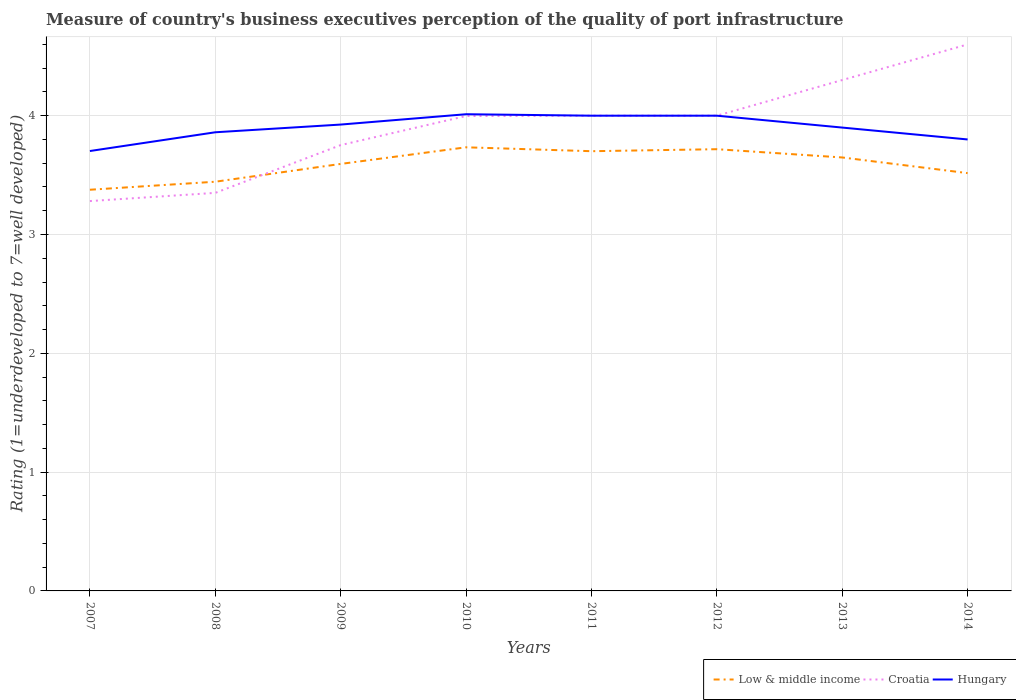Across all years, what is the maximum ratings of the quality of port infrastructure in Croatia?
Your answer should be compact. 3.28. What is the total ratings of the quality of port infrastructure in Hungary in the graph?
Keep it short and to the point. -0.3. What is the difference between the highest and the second highest ratings of the quality of port infrastructure in Croatia?
Your answer should be very brief. 1.32. How many lines are there?
Your answer should be compact. 3. How many years are there in the graph?
Give a very brief answer. 8. What is the difference between two consecutive major ticks on the Y-axis?
Provide a succinct answer. 1. Are the values on the major ticks of Y-axis written in scientific E-notation?
Your answer should be very brief. No. Where does the legend appear in the graph?
Your answer should be compact. Bottom right. How are the legend labels stacked?
Make the answer very short. Horizontal. What is the title of the graph?
Your response must be concise. Measure of country's business executives perception of the quality of port infrastructure. What is the label or title of the X-axis?
Make the answer very short. Years. What is the label or title of the Y-axis?
Your answer should be very brief. Rating (1=underdeveloped to 7=well developed). What is the Rating (1=underdeveloped to 7=well developed) in Low & middle income in 2007?
Give a very brief answer. 3.38. What is the Rating (1=underdeveloped to 7=well developed) in Croatia in 2007?
Offer a terse response. 3.28. What is the Rating (1=underdeveloped to 7=well developed) in Hungary in 2007?
Your answer should be very brief. 3.7. What is the Rating (1=underdeveloped to 7=well developed) in Low & middle income in 2008?
Make the answer very short. 3.44. What is the Rating (1=underdeveloped to 7=well developed) of Croatia in 2008?
Ensure brevity in your answer.  3.35. What is the Rating (1=underdeveloped to 7=well developed) of Hungary in 2008?
Ensure brevity in your answer.  3.86. What is the Rating (1=underdeveloped to 7=well developed) of Low & middle income in 2009?
Ensure brevity in your answer.  3.59. What is the Rating (1=underdeveloped to 7=well developed) in Croatia in 2009?
Provide a short and direct response. 3.75. What is the Rating (1=underdeveloped to 7=well developed) of Hungary in 2009?
Make the answer very short. 3.93. What is the Rating (1=underdeveloped to 7=well developed) of Low & middle income in 2010?
Give a very brief answer. 3.73. What is the Rating (1=underdeveloped to 7=well developed) of Croatia in 2010?
Give a very brief answer. 4. What is the Rating (1=underdeveloped to 7=well developed) of Hungary in 2010?
Make the answer very short. 4.01. What is the Rating (1=underdeveloped to 7=well developed) of Low & middle income in 2011?
Provide a succinct answer. 3.7. What is the Rating (1=underdeveloped to 7=well developed) in Croatia in 2011?
Keep it short and to the point. 4. What is the Rating (1=underdeveloped to 7=well developed) of Low & middle income in 2012?
Make the answer very short. 3.72. What is the Rating (1=underdeveloped to 7=well developed) of Hungary in 2012?
Your answer should be very brief. 4. What is the Rating (1=underdeveloped to 7=well developed) of Low & middle income in 2013?
Your answer should be compact. 3.65. What is the Rating (1=underdeveloped to 7=well developed) in Hungary in 2013?
Offer a very short reply. 3.9. What is the Rating (1=underdeveloped to 7=well developed) in Low & middle income in 2014?
Give a very brief answer. 3.52. What is the Rating (1=underdeveloped to 7=well developed) in Croatia in 2014?
Provide a succinct answer. 4.6. What is the Rating (1=underdeveloped to 7=well developed) of Hungary in 2014?
Your answer should be compact. 3.8. Across all years, what is the maximum Rating (1=underdeveloped to 7=well developed) in Low & middle income?
Make the answer very short. 3.73. Across all years, what is the maximum Rating (1=underdeveloped to 7=well developed) of Hungary?
Offer a very short reply. 4.01. Across all years, what is the minimum Rating (1=underdeveloped to 7=well developed) of Low & middle income?
Your answer should be compact. 3.38. Across all years, what is the minimum Rating (1=underdeveloped to 7=well developed) in Croatia?
Keep it short and to the point. 3.28. Across all years, what is the minimum Rating (1=underdeveloped to 7=well developed) of Hungary?
Your answer should be compact. 3.7. What is the total Rating (1=underdeveloped to 7=well developed) in Low & middle income in the graph?
Make the answer very short. 28.73. What is the total Rating (1=underdeveloped to 7=well developed) of Croatia in the graph?
Make the answer very short. 31.28. What is the total Rating (1=underdeveloped to 7=well developed) of Hungary in the graph?
Provide a short and direct response. 31.2. What is the difference between the Rating (1=underdeveloped to 7=well developed) of Low & middle income in 2007 and that in 2008?
Ensure brevity in your answer.  -0.07. What is the difference between the Rating (1=underdeveloped to 7=well developed) in Croatia in 2007 and that in 2008?
Keep it short and to the point. -0.07. What is the difference between the Rating (1=underdeveloped to 7=well developed) of Hungary in 2007 and that in 2008?
Make the answer very short. -0.16. What is the difference between the Rating (1=underdeveloped to 7=well developed) in Low & middle income in 2007 and that in 2009?
Provide a succinct answer. -0.22. What is the difference between the Rating (1=underdeveloped to 7=well developed) of Croatia in 2007 and that in 2009?
Provide a succinct answer. -0.47. What is the difference between the Rating (1=underdeveloped to 7=well developed) in Hungary in 2007 and that in 2009?
Ensure brevity in your answer.  -0.22. What is the difference between the Rating (1=underdeveloped to 7=well developed) in Low & middle income in 2007 and that in 2010?
Give a very brief answer. -0.36. What is the difference between the Rating (1=underdeveloped to 7=well developed) of Croatia in 2007 and that in 2010?
Ensure brevity in your answer.  -0.72. What is the difference between the Rating (1=underdeveloped to 7=well developed) in Hungary in 2007 and that in 2010?
Make the answer very short. -0.31. What is the difference between the Rating (1=underdeveloped to 7=well developed) in Low & middle income in 2007 and that in 2011?
Offer a very short reply. -0.32. What is the difference between the Rating (1=underdeveloped to 7=well developed) in Croatia in 2007 and that in 2011?
Your answer should be compact. -0.72. What is the difference between the Rating (1=underdeveloped to 7=well developed) of Hungary in 2007 and that in 2011?
Keep it short and to the point. -0.3. What is the difference between the Rating (1=underdeveloped to 7=well developed) of Low & middle income in 2007 and that in 2012?
Your answer should be compact. -0.34. What is the difference between the Rating (1=underdeveloped to 7=well developed) in Croatia in 2007 and that in 2012?
Ensure brevity in your answer.  -0.72. What is the difference between the Rating (1=underdeveloped to 7=well developed) of Hungary in 2007 and that in 2012?
Your answer should be very brief. -0.3. What is the difference between the Rating (1=underdeveloped to 7=well developed) in Low & middle income in 2007 and that in 2013?
Provide a short and direct response. -0.27. What is the difference between the Rating (1=underdeveloped to 7=well developed) in Croatia in 2007 and that in 2013?
Provide a short and direct response. -1.02. What is the difference between the Rating (1=underdeveloped to 7=well developed) of Hungary in 2007 and that in 2013?
Keep it short and to the point. -0.2. What is the difference between the Rating (1=underdeveloped to 7=well developed) in Low & middle income in 2007 and that in 2014?
Provide a short and direct response. -0.14. What is the difference between the Rating (1=underdeveloped to 7=well developed) of Croatia in 2007 and that in 2014?
Ensure brevity in your answer.  -1.32. What is the difference between the Rating (1=underdeveloped to 7=well developed) of Hungary in 2007 and that in 2014?
Keep it short and to the point. -0.1. What is the difference between the Rating (1=underdeveloped to 7=well developed) in Low & middle income in 2008 and that in 2009?
Offer a very short reply. -0.15. What is the difference between the Rating (1=underdeveloped to 7=well developed) in Croatia in 2008 and that in 2009?
Provide a short and direct response. -0.4. What is the difference between the Rating (1=underdeveloped to 7=well developed) of Hungary in 2008 and that in 2009?
Offer a very short reply. -0.06. What is the difference between the Rating (1=underdeveloped to 7=well developed) in Low & middle income in 2008 and that in 2010?
Offer a terse response. -0.29. What is the difference between the Rating (1=underdeveloped to 7=well developed) in Croatia in 2008 and that in 2010?
Your answer should be compact. -0.65. What is the difference between the Rating (1=underdeveloped to 7=well developed) in Hungary in 2008 and that in 2010?
Offer a very short reply. -0.15. What is the difference between the Rating (1=underdeveloped to 7=well developed) of Low & middle income in 2008 and that in 2011?
Provide a succinct answer. -0.26. What is the difference between the Rating (1=underdeveloped to 7=well developed) of Croatia in 2008 and that in 2011?
Offer a terse response. -0.65. What is the difference between the Rating (1=underdeveloped to 7=well developed) of Hungary in 2008 and that in 2011?
Your response must be concise. -0.14. What is the difference between the Rating (1=underdeveloped to 7=well developed) in Low & middle income in 2008 and that in 2012?
Your answer should be very brief. -0.27. What is the difference between the Rating (1=underdeveloped to 7=well developed) in Croatia in 2008 and that in 2012?
Your answer should be compact. -0.65. What is the difference between the Rating (1=underdeveloped to 7=well developed) in Hungary in 2008 and that in 2012?
Provide a short and direct response. -0.14. What is the difference between the Rating (1=underdeveloped to 7=well developed) in Low & middle income in 2008 and that in 2013?
Give a very brief answer. -0.2. What is the difference between the Rating (1=underdeveloped to 7=well developed) of Croatia in 2008 and that in 2013?
Provide a succinct answer. -0.95. What is the difference between the Rating (1=underdeveloped to 7=well developed) of Hungary in 2008 and that in 2013?
Offer a terse response. -0.04. What is the difference between the Rating (1=underdeveloped to 7=well developed) of Low & middle income in 2008 and that in 2014?
Ensure brevity in your answer.  -0.07. What is the difference between the Rating (1=underdeveloped to 7=well developed) in Croatia in 2008 and that in 2014?
Make the answer very short. -1.25. What is the difference between the Rating (1=underdeveloped to 7=well developed) of Hungary in 2008 and that in 2014?
Ensure brevity in your answer.  0.06. What is the difference between the Rating (1=underdeveloped to 7=well developed) of Low & middle income in 2009 and that in 2010?
Offer a very short reply. -0.14. What is the difference between the Rating (1=underdeveloped to 7=well developed) in Croatia in 2009 and that in 2010?
Your response must be concise. -0.24. What is the difference between the Rating (1=underdeveloped to 7=well developed) of Hungary in 2009 and that in 2010?
Your response must be concise. -0.09. What is the difference between the Rating (1=underdeveloped to 7=well developed) of Low & middle income in 2009 and that in 2011?
Make the answer very short. -0.11. What is the difference between the Rating (1=underdeveloped to 7=well developed) in Croatia in 2009 and that in 2011?
Your answer should be compact. -0.25. What is the difference between the Rating (1=underdeveloped to 7=well developed) in Hungary in 2009 and that in 2011?
Keep it short and to the point. -0.07. What is the difference between the Rating (1=underdeveloped to 7=well developed) of Low & middle income in 2009 and that in 2012?
Provide a succinct answer. -0.12. What is the difference between the Rating (1=underdeveloped to 7=well developed) of Croatia in 2009 and that in 2012?
Offer a very short reply. -0.25. What is the difference between the Rating (1=underdeveloped to 7=well developed) of Hungary in 2009 and that in 2012?
Provide a succinct answer. -0.07. What is the difference between the Rating (1=underdeveloped to 7=well developed) in Low & middle income in 2009 and that in 2013?
Your answer should be compact. -0.05. What is the difference between the Rating (1=underdeveloped to 7=well developed) in Croatia in 2009 and that in 2013?
Your answer should be very brief. -0.55. What is the difference between the Rating (1=underdeveloped to 7=well developed) in Hungary in 2009 and that in 2013?
Your response must be concise. 0.03. What is the difference between the Rating (1=underdeveloped to 7=well developed) in Low & middle income in 2009 and that in 2014?
Offer a terse response. 0.08. What is the difference between the Rating (1=underdeveloped to 7=well developed) of Croatia in 2009 and that in 2014?
Keep it short and to the point. -0.85. What is the difference between the Rating (1=underdeveloped to 7=well developed) in Hungary in 2009 and that in 2014?
Provide a short and direct response. 0.13. What is the difference between the Rating (1=underdeveloped to 7=well developed) of Low & middle income in 2010 and that in 2011?
Your answer should be very brief. 0.03. What is the difference between the Rating (1=underdeveloped to 7=well developed) of Croatia in 2010 and that in 2011?
Your response must be concise. -0. What is the difference between the Rating (1=underdeveloped to 7=well developed) of Hungary in 2010 and that in 2011?
Ensure brevity in your answer.  0.01. What is the difference between the Rating (1=underdeveloped to 7=well developed) of Low & middle income in 2010 and that in 2012?
Your answer should be compact. 0.02. What is the difference between the Rating (1=underdeveloped to 7=well developed) in Croatia in 2010 and that in 2012?
Ensure brevity in your answer.  -0. What is the difference between the Rating (1=underdeveloped to 7=well developed) in Hungary in 2010 and that in 2012?
Your answer should be very brief. 0.01. What is the difference between the Rating (1=underdeveloped to 7=well developed) in Low & middle income in 2010 and that in 2013?
Offer a terse response. 0.09. What is the difference between the Rating (1=underdeveloped to 7=well developed) of Croatia in 2010 and that in 2013?
Ensure brevity in your answer.  -0.3. What is the difference between the Rating (1=underdeveloped to 7=well developed) of Hungary in 2010 and that in 2013?
Your answer should be compact. 0.11. What is the difference between the Rating (1=underdeveloped to 7=well developed) of Low & middle income in 2010 and that in 2014?
Give a very brief answer. 0.22. What is the difference between the Rating (1=underdeveloped to 7=well developed) of Croatia in 2010 and that in 2014?
Your response must be concise. -0.6. What is the difference between the Rating (1=underdeveloped to 7=well developed) in Hungary in 2010 and that in 2014?
Your answer should be compact. 0.21. What is the difference between the Rating (1=underdeveloped to 7=well developed) of Low & middle income in 2011 and that in 2012?
Provide a short and direct response. -0.02. What is the difference between the Rating (1=underdeveloped to 7=well developed) of Croatia in 2011 and that in 2012?
Ensure brevity in your answer.  0. What is the difference between the Rating (1=underdeveloped to 7=well developed) in Low & middle income in 2011 and that in 2013?
Your answer should be very brief. 0.05. What is the difference between the Rating (1=underdeveloped to 7=well developed) of Low & middle income in 2011 and that in 2014?
Provide a short and direct response. 0.18. What is the difference between the Rating (1=underdeveloped to 7=well developed) in Croatia in 2011 and that in 2014?
Your answer should be very brief. -0.6. What is the difference between the Rating (1=underdeveloped to 7=well developed) of Low & middle income in 2012 and that in 2013?
Make the answer very short. 0.07. What is the difference between the Rating (1=underdeveloped to 7=well developed) in Croatia in 2012 and that in 2013?
Your answer should be very brief. -0.3. What is the difference between the Rating (1=underdeveloped to 7=well developed) in Hungary in 2012 and that in 2013?
Make the answer very short. 0.1. What is the difference between the Rating (1=underdeveloped to 7=well developed) in Low & middle income in 2012 and that in 2014?
Make the answer very short. 0.2. What is the difference between the Rating (1=underdeveloped to 7=well developed) in Hungary in 2012 and that in 2014?
Provide a short and direct response. 0.2. What is the difference between the Rating (1=underdeveloped to 7=well developed) of Low & middle income in 2013 and that in 2014?
Keep it short and to the point. 0.13. What is the difference between the Rating (1=underdeveloped to 7=well developed) in Hungary in 2013 and that in 2014?
Keep it short and to the point. 0.1. What is the difference between the Rating (1=underdeveloped to 7=well developed) in Low & middle income in 2007 and the Rating (1=underdeveloped to 7=well developed) in Croatia in 2008?
Give a very brief answer. 0.03. What is the difference between the Rating (1=underdeveloped to 7=well developed) in Low & middle income in 2007 and the Rating (1=underdeveloped to 7=well developed) in Hungary in 2008?
Make the answer very short. -0.48. What is the difference between the Rating (1=underdeveloped to 7=well developed) of Croatia in 2007 and the Rating (1=underdeveloped to 7=well developed) of Hungary in 2008?
Make the answer very short. -0.58. What is the difference between the Rating (1=underdeveloped to 7=well developed) in Low & middle income in 2007 and the Rating (1=underdeveloped to 7=well developed) in Croatia in 2009?
Your answer should be compact. -0.38. What is the difference between the Rating (1=underdeveloped to 7=well developed) in Low & middle income in 2007 and the Rating (1=underdeveloped to 7=well developed) in Hungary in 2009?
Your answer should be very brief. -0.55. What is the difference between the Rating (1=underdeveloped to 7=well developed) in Croatia in 2007 and the Rating (1=underdeveloped to 7=well developed) in Hungary in 2009?
Your answer should be very brief. -0.64. What is the difference between the Rating (1=underdeveloped to 7=well developed) in Low & middle income in 2007 and the Rating (1=underdeveloped to 7=well developed) in Croatia in 2010?
Provide a short and direct response. -0.62. What is the difference between the Rating (1=underdeveloped to 7=well developed) in Low & middle income in 2007 and the Rating (1=underdeveloped to 7=well developed) in Hungary in 2010?
Provide a succinct answer. -0.64. What is the difference between the Rating (1=underdeveloped to 7=well developed) of Croatia in 2007 and the Rating (1=underdeveloped to 7=well developed) of Hungary in 2010?
Make the answer very short. -0.73. What is the difference between the Rating (1=underdeveloped to 7=well developed) of Low & middle income in 2007 and the Rating (1=underdeveloped to 7=well developed) of Croatia in 2011?
Provide a succinct answer. -0.62. What is the difference between the Rating (1=underdeveloped to 7=well developed) in Low & middle income in 2007 and the Rating (1=underdeveloped to 7=well developed) in Hungary in 2011?
Your response must be concise. -0.62. What is the difference between the Rating (1=underdeveloped to 7=well developed) of Croatia in 2007 and the Rating (1=underdeveloped to 7=well developed) of Hungary in 2011?
Your response must be concise. -0.72. What is the difference between the Rating (1=underdeveloped to 7=well developed) in Low & middle income in 2007 and the Rating (1=underdeveloped to 7=well developed) in Croatia in 2012?
Make the answer very short. -0.62. What is the difference between the Rating (1=underdeveloped to 7=well developed) in Low & middle income in 2007 and the Rating (1=underdeveloped to 7=well developed) in Hungary in 2012?
Keep it short and to the point. -0.62. What is the difference between the Rating (1=underdeveloped to 7=well developed) in Croatia in 2007 and the Rating (1=underdeveloped to 7=well developed) in Hungary in 2012?
Offer a terse response. -0.72. What is the difference between the Rating (1=underdeveloped to 7=well developed) in Low & middle income in 2007 and the Rating (1=underdeveloped to 7=well developed) in Croatia in 2013?
Your answer should be very brief. -0.92. What is the difference between the Rating (1=underdeveloped to 7=well developed) of Low & middle income in 2007 and the Rating (1=underdeveloped to 7=well developed) of Hungary in 2013?
Your response must be concise. -0.52. What is the difference between the Rating (1=underdeveloped to 7=well developed) in Croatia in 2007 and the Rating (1=underdeveloped to 7=well developed) in Hungary in 2013?
Offer a very short reply. -0.62. What is the difference between the Rating (1=underdeveloped to 7=well developed) of Low & middle income in 2007 and the Rating (1=underdeveloped to 7=well developed) of Croatia in 2014?
Offer a very short reply. -1.22. What is the difference between the Rating (1=underdeveloped to 7=well developed) of Low & middle income in 2007 and the Rating (1=underdeveloped to 7=well developed) of Hungary in 2014?
Make the answer very short. -0.42. What is the difference between the Rating (1=underdeveloped to 7=well developed) of Croatia in 2007 and the Rating (1=underdeveloped to 7=well developed) of Hungary in 2014?
Offer a very short reply. -0.52. What is the difference between the Rating (1=underdeveloped to 7=well developed) of Low & middle income in 2008 and the Rating (1=underdeveloped to 7=well developed) of Croatia in 2009?
Ensure brevity in your answer.  -0.31. What is the difference between the Rating (1=underdeveloped to 7=well developed) of Low & middle income in 2008 and the Rating (1=underdeveloped to 7=well developed) of Hungary in 2009?
Provide a succinct answer. -0.48. What is the difference between the Rating (1=underdeveloped to 7=well developed) of Croatia in 2008 and the Rating (1=underdeveloped to 7=well developed) of Hungary in 2009?
Provide a short and direct response. -0.57. What is the difference between the Rating (1=underdeveloped to 7=well developed) of Low & middle income in 2008 and the Rating (1=underdeveloped to 7=well developed) of Croatia in 2010?
Your response must be concise. -0.55. What is the difference between the Rating (1=underdeveloped to 7=well developed) in Low & middle income in 2008 and the Rating (1=underdeveloped to 7=well developed) in Hungary in 2010?
Make the answer very short. -0.57. What is the difference between the Rating (1=underdeveloped to 7=well developed) in Croatia in 2008 and the Rating (1=underdeveloped to 7=well developed) in Hungary in 2010?
Keep it short and to the point. -0.66. What is the difference between the Rating (1=underdeveloped to 7=well developed) of Low & middle income in 2008 and the Rating (1=underdeveloped to 7=well developed) of Croatia in 2011?
Ensure brevity in your answer.  -0.56. What is the difference between the Rating (1=underdeveloped to 7=well developed) of Low & middle income in 2008 and the Rating (1=underdeveloped to 7=well developed) of Hungary in 2011?
Keep it short and to the point. -0.56. What is the difference between the Rating (1=underdeveloped to 7=well developed) in Croatia in 2008 and the Rating (1=underdeveloped to 7=well developed) in Hungary in 2011?
Offer a very short reply. -0.65. What is the difference between the Rating (1=underdeveloped to 7=well developed) of Low & middle income in 2008 and the Rating (1=underdeveloped to 7=well developed) of Croatia in 2012?
Your answer should be compact. -0.56. What is the difference between the Rating (1=underdeveloped to 7=well developed) of Low & middle income in 2008 and the Rating (1=underdeveloped to 7=well developed) of Hungary in 2012?
Ensure brevity in your answer.  -0.56. What is the difference between the Rating (1=underdeveloped to 7=well developed) in Croatia in 2008 and the Rating (1=underdeveloped to 7=well developed) in Hungary in 2012?
Ensure brevity in your answer.  -0.65. What is the difference between the Rating (1=underdeveloped to 7=well developed) in Low & middle income in 2008 and the Rating (1=underdeveloped to 7=well developed) in Croatia in 2013?
Give a very brief answer. -0.86. What is the difference between the Rating (1=underdeveloped to 7=well developed) of Low & middle income in 2008 and the Rating (1=underdeveloped to 7=well developed) of Hungary in 2013?
Provide a succinct answer. -0.46. What is the difference between the Rating (1=underdeveloped to 7=well developed) of Croatia in 2008 and the Rating (1=underdeveloped to 7=well developed) of Hungary in 2013?
Your answer should be very brief. -0.55. What is the difference between the Rating (1=underdeveloped to 7=well developed) of Low & middle income in 2008 and the Rating (1=underdeveloped to 7=well developed) of Croatia in 2014?
Provide a short and direct response. -1.16. What is the difference between the Rating (1=underdeveloped to 7=well developed) in Low & middle income in 2008 and the Rating (1=underdeveloped to 7=well developed) in Hungary in 2014?
Your answer should be compact. -0.36. What is the difference between the Rating (1=underdeveloped to 7=well developed) in Croatia in 2008 and the Rating (1=underdeveloped to 7=well developed) in Hungary in 2014?
Your answer should be compact. -0.45. What is the difference between the Rating (1=underdeveloped to 7=well developed) of Low & middle income in 2009 and the Rating (1=underdeveloped to 7=well developed) of Croatia in 2010?
Your answer should be compact. -0.4. What is the difference between the Rating (1=underdeveloped to 7=well developed) in Low & middle income in 2009 and the Rating (1=underdeveloped to 7=well developed) in Hungary in 2010?
Keep it short and to the point. -0.42. What is the difference between the Rating (1=underdeveloped to 7=well developed) in Croatia in 2009 and the Rating (1=underdeveloped to 7=well developed) in Hungary in 2010?
Provide a short and direct response. -0.26. What is the difference between the Rating (1=underdeveloped to 7=well developed) in Low & middle income in 2009 and the Rating (1=underdeveloped to 7=well developed) in Croatia in 2011?
Ensure brevity in your answer.  -0.41. What is the difference between the Rating (1=underdeveloped to 7=well developed) of Low & middle income in 2009 and the Rating (1=underdeveloped to 7=well developed) of Hungary in 2011?
Give a very brief answer. -0.41. What is the difference between the Rating (1=underdeveloped to 7=well developed) of Croatia in 2009 and the Rating (1=underdeveloped to 7=well developed) of Hungary in 2011?
Provide a succinct answer. -0.25. What is the difference between the Rating (1=underdeveloped to 7=well developed) of Low & middle income in 2009 and the Rating (1=underdeveloped to 7=well developed) of Croatia in 2012?
Give a very brief answer. -0.41. What is the difference between the Rating (1=underdeveloped to 7=well developed) in Low & middle income in 2009 and the Rating (1=underdeveloped to 7=well developed) in Hungary in 2012?
Your answer should be compact. -0.41. What is the difference between the Rating (1=underdeveloped to 7=well developed) of Croatia in 2009 and the Rating (1=underdeveloped to 7=well developed) of Hungary in 2012?
Make the answer very short. -0.25. What is the difference between the Rating (1=underdeveloped to 7=well developed) of Low & middle income in 2009 and the Rating (1=underdeveloped to 7=well developed) of Croatia in 2013?
Offer a very short reply. -0.71. What is the difference between the Rating (1=underdeveloped to 7=well developed) of Low & middle income in 2009 and the Rating (1=underdeveloped to 7=well developed) of Hungary in 2013?
Provide a succinct answer. -0.31. What is the difference between the Rating (1=underdeveloped to 7=well developed) in Croatia in 2009 and the Rating (1=underdeveloped to 7=well developed) in Hungary in 2013?
Your response must be concise. -0.15. What is the difference between the Rating (1=underdeveloped to 7=well developed) of Low & middle income in 2009 and the Rating (1=underdeveloped to 7=well developed) of Croatia in 2014?
Ensure brevity in your answer.  -1.01. What is the difference between the Rating (1=underdeveloped to 7=well developed) of Low & middle income in 2009 and the Rating (1=underdeveloped to 7=well developed) of Hungary in 2014?
Offer a very short reply. -0.21. What is the difference between the Rating (1=underdeveloped to 7=well developed) of Croatia in 2009 and the Rating (1=underdeveloped to 7=well developed) of Hungary in 2014?
Your answer should be very brief. -0.05. What is the difference between the Rating (1=underdeveloped to 7=well developed) of Low & middle income in 2010 and the Rating (1=underdeveloped to 7=well developed) of Croatia in 2011?
Your answer should be very brief. -0.27. What is the difference between the Rating (1=underdeveloped to 7=well developed) of Low & middle income in 2010 and the Rating (1=underdeveloped to 7=well developed) of Hungary in 2011?
Ensure brevity in your answer.  -0.27. What is the difference between the Rating (1=underdeveloped to 7=well developed) in Croatia in 2010 and the Rating (1=underdeveloped to 7=well developed) in Hungary in 2011?
Provide a short and direct response. -0. What is the difference between the Rating (1=underdeveloped to 7=well developed) of Low & middle income in 2010 and the Rating (1=underdeveloped to 7=well developed) of Croatia in 2012?
Keep it short and to the point. -0.27. What is the difference between the Rating (1=underdeveloped to 7=well developed) of Low & middle income in 2010 and the Rating (1=underdeveloped to 7=well developed) of Hungary in 2012?
Provide a short and direct response. -0.27. What is the difference between the Rating (1=underdeveloped to 7=well developed) of Croatia in 2010 and the Rating (1=underdeveloped to 7=well developed) of Hungary in 2012?
Give a very brief answer. -0. What is the difference between the Rating (1=underdeveloped to 7=well developed) of Low & middle income in 2010 and the Rating (1=underdeveloped to 7=well developed) of Croatia in 2013?
Keep it short and to the point. -0.57. What is the difference between the Rating (1=underdeveloped to 7=well developed) in Low & middle income in 2010 and the Rating (1=underdeveloped to 7=well developed) in Hungary in 2013?
Your answer should be compact. -0.17. What is the difference between the Rating (1=underdeveloped to 7=well developed) in Croatia in 2010 and the Rating (1=underdeveloped to 7=well developed) in Hungary in 2013?
Give a very brief answer. 0.1. What is the difference between the Rating (1=underdeveloped to 7=well developed) in Low & middle income in 2010 and the Rating (1=underdeveloped to 7=well developed) in Croatia in 2014?
Keep it short and to the point. -0.87. What is the difference between the Rating (1=underdeveloped to 7=well developed) in Low & middle income in 2010 and the Rating (1=underdeveloped to 7=well developed) in Hungary in 2014?
Your answer should be compact. -0.07. What is the difference between the Rating (1=underdeveloped to 7=well developed) in Croatia in 2010 and the Rating (1=underdeveloped to 7=well developed) in Hungary in 2014?
Offer a terse response. 0.2. What is the difference between the Rating (1=underdeveloped to 7=well developed) in Low & middle income in 2011 and the Rating (1=underdeveloped to 7=well developed) in Croatia in 2012?
Offer a very short reply. -0.3. What is the difference between the Rating (1=underdeveloped to 7=well developed) of Low & middle income in 2011 and the Rating (1=underdeveloped to 7=well developed) of Hungary in 2012?
Offer a terse response. -0.3. What is the difference between the Rating (1=underdeveloped to 7=well developed) of Croatia in 2011 and the Rating (1=underdeveloped to 7=well developed) of Hungary in 2012?
Give a very brief answer. 0. What is the difference between the Rating (1=underdeveloped to 7=well developed) in Low & middle income in 2011 and the Rating (1=underdeveloped to 7=well developed) in Croatia in 2013?
Keep it short and to the point. -0.6. What is the difference between the Rating (1=underdeveloped to 7=well developed) in Low & middle income in 2011 and the Rating (1=underdeveloped to 7=well developed) in Hungary in 2013?
Keep it short and to the point. -0.2. What is the difference between the Rating (1=underdeveloped to 7=well developed) in Low & middle income in 2011 and the Rating (1=underdeveloped to 7=well developed) in Croatia in 2014?
Make the answer very short. -0.9. What is the difference between the Rating (1=underdeveloped to 7=well developed) of Low & middle income in 2011 and the Rating (1=underdeveloped to 7=well developed) of Hungary in 2014?
Provide a succinct answer. -0.1. What is the difference between the Rating (1=underdeveloped to 7=well developed) of Low & middle income in 2012 and the Rating (1=underdeveloped to 7=well developed) of Croatia in 2013?
Offer a terse response. -0.58. What is the difference between the Rating (1=underdeveloped to 7=well developed) of Low & middle income in 2012 and the Rating (1=underdeveloped to 7=well developed) of Hungary in 2013?
Offer a very short reply. -0.18. What is the difference between the Rating (1=underdeveloped to 7=well developed) in Low & middle income in 2012 and the Rating (1=underdeveloped to 7=well developed) in Croatia in 2014?
Provide a short and direct response. -0.88. What is the difference between the Rating (1=underdeveloped to 7=well developed) in Low & middle income in 2012 and the Rating (1=underdeveloped to 7=well developed) in Hungary in 2014?
Provide a succinct answer. -0.08. What is the difference between the Rating (1=underdeveloped to 7=well developed) of Low & middle income in 2013 and the Rating (1=underdeveloped to 7=well developed) of Croatia in 2014?
Make the answer very short. -0.95. What is the difference between the Rating (1=underdeveloped to 7=well developed) in Low & middle income in 2013 and the Rating (1=underdeveloped to 7=well developed) in Hungary in 2014?
Ensure brevity in your answer.  -0.15. What is the difference between the Rating (1=underdeveloped to 7=well developed) in Croatia in 2013 and the Rating (1=underdeveloped to 7=well developed) in Hungary in 2014?
Offer a very short reply. 0.5. What is the average Rating (1=underdeveloped to 7=well developed) of Low & middle income per year?
Provide a short and direct response. 3.59. What is the average Rating (1=underdeveloped to 7=well developed) in Croatia per year?
Keep it short and to the point. 3.91. What is the average Rating (1=underdeveloped to 7=well developed) of Hungary per year?
Your response must be concise. 3.9. In the year 2007, what is the difference between the Rating (1=underdeveloped to 7=well developed) of Low & middle income and Rating (1=underdeveloped to 7=well developed) of Croatia?
Your answer should be very brief. 0.1. In the year 2007, what is the difference between the Rating (1=underdeveloped to 7=well developed) in Low & middle income and Rating (1=underdeveloped to 7=well developed) in Hungary?
Keep it short and to the point. -0.33. In the year 2007, what is the difference between the Rating (1=underdeveloped to 7=well developed) in Croatia and Rating (1=underdeveloped to 7=well developed) in Hungary?
Provide a short and direct response. -0.42. In the year 2008, what is the difference between the Rating (1=underdeveloped to 7=well developed) in Low & middle income and Rating (1=underdeveloped to 7=well developed) in Croatia?
Give a very brief answer. 0.09. In the year 2008, what is the difference between the Rating (1=underdeveloped to 7=well developed) in Low & middle income and Rating (1=underdeveloped to 7=well developed) in Hungary?
Offer a very short reply. -0.42. In the year 2008, what is the difference between the Rating (1=underdeveloped to 7=well developed) in Croatia and Rating (1=underdeveloped to 7=well developed) in Hungary?
Provide a short and direct response. -0.51. In the year 2009, what is the difference between the Rating (1=underdeveloped to 7=well developed) in Low & middle income and Rating (1=underdeveloped to 7=well developed) in Croatia?
Ensure brevity in your answer.  -0.16. In the year 2009, what is the difference between the Rating (1=underdeveloped to 7=well developed) of Low & middle income and Rating (1=underdeveloped to 7=well developed) of Hungary?
Offer a very short reply. -0.33. In the year 2009, what is the difference between the Rating (1=underdeveloped to 7=well developed) in Croatia and Rating (1=underdeveloped to 7=well developed) in Hungary?
Offer a very short reply. -0.17. In the year 2010, what is the difference between the Rating (1=underdeveloped to 7=well developed) of Low & middle income and Rating (1=underdeveloped to 7=well developed) of Croatia?
Your answer should be very brief. -0.26. In the year 2010, what is the difference between the Rating (1=underdeveloped to 7=well developed) in Low & middle income and Rating (1=underdeveloped to 7=well developed) in Hungary?
Your answer should be very brief. -0.28. In the year 2010, what is the difference between the Rating (1=underdeveloped to 7=well developed) of Croatia and Rating (1=underdeveloped to 7=well developed) of Hungary?
Your answer should be compact. -0.01. In the year 2011, what is the difference between the Rating (1=underdeveloped to 7=well developed) of Low & middle income and Rating (1=underdeveloped to 7=well developed) of Croatia?
Keep it short and to the point. -0.3. In the year 2011, what is the difference between the Rating (1=underdeveloped to 7=well developed) of Low & middle income and Rating (1=underdeveloped to 7=well developed) of Hungary?
Make the answer very short. -0.3. In the year 2012, what is the difference between the Rating (1=underdeveloped to 7=well developed) of Low & middle income and Rating (1=underdeveloped to 7=well developed) of Croatia?
Your answer should be very brief. -0.28. In the year 2012, what is the difference between the Rating (1=underdeveloped to 7=well developed) in Low & middle income and Rating (1=underdeveloped to 7=well developed) in Hungary?
Your answer should be compact. -0.28. In the year 2012, what is the difference between the Rating (1=underdeveloped to 7=well developed) in Croatia and Rating (1=underdeveloped to 7=well developed) in Hungary?
Provide a succinct answer. 0. In the year 2013, what is the difference between the Rating (1=underdeveloped to 7=well developed) in Low & middle income and Rating (1=underdeveloped to 7=well developed) in Croatia?
Provide a short and direct response. -0.65. In the year 2013, what is the difference between the Rating (1=underdeveloped to 7=well developed) in Low & middle income and Rating (1=underdeveloped to 7=well developed) in Hungary?
Provide a succinct answer. -0.25. In the year 2013, what is the difference between the Rating (1=underdeveloped to 7=well developed) of Croatia and Rating (1=underdeveloped to 7=well developed) of Hungary?
Your answer should be very brief. 0.4. In the year 2014, what is the difference between the Rating (1=underdeveloped to 7=well developed) in Low & middle income and Rating (1=underdeveloped to 7=well developed) in Croatia?
Provide a short and direct response. -1.08. In the year 2014, what is the difference between the Rating (1=underdeveloped to 7=well developed) of Low & middle income and Rating (1=underdeveloped to 7=well developed) of Hungary?
Keep it short and to the point. -0.28. What is the ratio of the Rating (1=underdeveloped to 7=well developed) of Low & middle income in 2007 to that in 2008?
Your response must be concise. 0.98. What is the ratio of the Rating (1=underdeveloped to 7=well developed) in Croatia in 2007 to that in 2008?
Offer a very short reply. 0.98. What is the ratio of the Rating (1=underdeveloped to 7=well developed) in Hungary in 2007 to that in 2008?
Offer a very short reply. 0.96. What is the ratio of the Rating (1=underdeveloped to 7=well developed) in Low & middle income in 2007 to that in 2009?
Offer a very short reply. 0.94. What is the ratio of the Rating (1=underdeveloped to 7=well developed) in Croatia in 2007 to that in 2009?
Give a very brief answer. 0.87. What is the ratio of the Rating (1=underdeveloped to 7=well developed) of Hungary in 2007 to that in 2009?
Your answer should be compact. 0.94. What is the ratio of the Rating (1=underdeveloped to 7=well developed) in Low & middle income in 2007 to that in 2010?
Offer a very short reply. 0.9. What is the ratio of the Rating (1=underdeveloped to 7=well developed) in Croatia in 2007 to that in 2010?
Give a very brief answer. 0.82. What is the ratio of the Rating (1=underdeveloped to 7=well developed) of Hungary in 2007 to that in 2010?
Your response must be concise. 0.92. What is the ratio of the Rating (1=underdeveloped to 7=well developed) in Low & middle income in 2007 to that in 2011?
Keep it short and to the point. 0.91. What is the ratio of the Rating (1=underdeveloped to 7=well developed) in Croatia in 2007 to that in 2011?
Keep it short and to the point. 0.82. What is the ratio of the Rating (1=underdeveloped to 7=well developed) of Hungary in 2007 to that in 2011?
Offer a very short reply. 0.93. What is the ratio of the Rating (1=underdeveloped to 7=well developed) in Low & middle income in 2007 to that in 2012?
Make the answer very short. 0.91. What is the ratio of the Rating (1=underdeveloped to 7=well developed) in Croatia in 2007 to that in 2012?
Give a very brief answer. 0.82. What is the ratio of the Rating (1=underdeveloped to 7=well developed) in Hungary in 2007 to that in 2012?
Keep it short and to the point. 0.93. What is the ratio of the Rating (1=underdeveloped to 7=well developed) of Low & middle income in 2007 to that in 2013?
Offer a very short reply. 0.93. What is the ratio of the Rating (1=underdeveloped to 7=well developed) of Croatia in 2007 to that in 2013?
Ensure brevity in your answer.  0.76. What is the ratio of the Rating (1=underdeveloped to 7=well developed) in Hungary in 2007 to that in 2013?
Provide a succinct answer. 0.95. What is the ratio of the Rating (1=underdeveloped to 7=well developed) in Low & middle income in 2007 to that in 2014?
Offer a very short reply. 0.96. What is the ratio of the Rating (1=underdeveloped to 7=well developed) in Croatia in 2007 to that in 2014?
Provide a succinct answer. 0.71. What is the ratio of the Rating (1=underdeveloped to 7=well developed) in Hungary in 2007 to that in 2014?
Give a very brief answer. 0.97. What is the ratio of the Rating (1=underdeveloped to 7=well developed) in Croatia in 2008 to that in 2009?
Provide a succinct answer. 0.89. What is the ratio of the Rating (1=underdeveloped to 7=well developed) of Hungary in 2008 to that in 2009?
Make the answer very short. 0.98. What is the ratio of the Rating (1=underdeveloped to 7=well developed) of Low & middle income in 2008 to that in 2010?
Provide a short and direct response. 0.92. What is the ratio of the Rating (1=underdeveloped to 7=well developed) in Croatia in 2008 to that in 2010?
Offer a very short reply. 0.84. What is the ratio of the Rating (1=underdeveloped to 7=well developed) in Hungary in 2008 to that in 2010?
Ensure brevity in your answer.  0.96. What is the ratio of the Rating (1=underdeveloped to 7=well developed) of Low & middle income in 2008 to that in 2011?
Offer a very short reply. 0.93. What is the ratio of the Rating (1=underdeveloped to 7=well developed) of Croatia in 2008 to that in 2011?
Offer a terse response. 0.84. What is the ratio of the Rating (1=underdeveloped to 7=well developed) in Hungary in 2008 to that in 2011?
Your answer should be compact. 0.97. What is the ratio of the Rating (1=underdeveloped to 7=well developed) of Low & middle income in 2008 to that in 2012?
Offer a terse response. 0.93. What is the ratio of the Rating (1=underdeveloped to 7=well developed) of Croatia in 2008 to that in 2012?
Your response must be concise. 0.84. What is the ratio of the Rating (1=underdeveloped to 7=well developed) of Hungary in 2008 to that in 2012?
Provide a short and direct response. 0.97. What is the ratio of the Rating (1=underdeveloped to 7=well developed) of Low & middle income in 2008 to that in 2013?
Your answer should be very brief. 0.94. What is the ratio of the Rating (1=underdeveloped to 7=well developed) in Croatia in 2008 to that in 2013?
Give a very brief answer. 0.78. What is the ratio of the Rating (1=underdeveloped to 7=well developed) in Low & middle income in 2008 to that in 2014?
Provide a succinct answer. 0.98. What is the ratio of the Rating (1=underdeveloped to 7=well developed) of Croatia in 2008 to that in 2014?
Your answer should be compact. 0.73. What is the ratio of the Rating (1=underdeveloped to 7=well developed) of Hungary in 2008 to that in 2014?
Make the answer very short. 1.02. What is the ratio of the Rating (1=underdeveloped to 7=well developed) in Low & middle income in 2009 to that in 2010?
Your answer should be compact. 0.96. What is the ratio of the Rating (1=underdeveloped to 7=well developed) of Croatia in 2009 to that in 2010?
Offer a terse response. 0.94. What is the ratio of the Rating (1=underdeveloped to 7=well developed) in Hungary in 2009 to that in 2010?
Keep it short and to the point. 0.98. What is the ratio of the Rating (1=underdeveloped to 7=well developed) in Low & middle income in 2009 to that in 2011?
Provide a succinct answer. 0.97. What is the ratio of the Rating (1=underdeveloped to 7=well developed) in Croatia in 2009 to that in 2011?
Give a very brief answer. 0.94. What is the ratio of the Rating (1=underdeveloped to 7=well developed) of Hungary in 2009 to that in 2011?
Provide a succinct answer. 0.98. What is the ratio of the Rating (1=underdeveloped to 7=well developed) in Low & middle income in 2009 to that in 2012?
Offer a terse response. 0.97. What is the ratio of the Rating (1=underdeveloped to 7=well developed) of Croatia in 2009 to that in 2012?
Give a very brief answer. 0.94. What is the ratio of the Rating (1=underdeveloped to 7=well developed) in Hungary in 2009 to that in 2012?
Ensure brevity in your answer.  0.98. What is the ratio of the Rating (1=underdeveloped to 7=well developed) of Low & middle income in 2009 to that in 2013?
Make the answer very short. 0.99. What is the ratio of the Rating (1=underdeveloped to 7=well developed) in Croatia in 2009 to that in 2013?
Offer a terse response. 0.87. What is the ratio of the Rating (1=underdeveloped to 7=well developed) of Croatia in 2009 to that in 2014?
Provide a succinct answer. 0.82. What is the ratio of the Rating (1=underdeveloped to 7=well developed) in Hungary in 2009 to that in 2014?
Give a very brief answer. 1.03. What is the ratio of the Rating (1=underdeveloped to 7=well developed) of Low & middle income in 2010 to that in 2011?
Offer a very short reply. 1.01. What is the ratio of the Rating (1=underdeveloped to 7=well developed) of Croatia in 2010 to that in 2011?
Offer a very short reply. 1. What is the ratio of the Rating (1=underdeveloped to 7=well developed) of Hungary in 2010 to that in 2011?
Provide a short and direct response. 1. What is the ratio of the Rating (1=underdeveloped to 7=well developed) of Croatia in 2010 to that in 2012?
Provide a succinct answer. 1. What is the ratio of the Rating (1=underdeveloped to 7=well developed) of Low & middle income in 2010 to that in 2013?
Your answer should be very brief. 1.02. What is the ratio of the Rating (1=underdeveloped to 7=well developed) in Croatia in 2010 to that in 2013?
Ensure brevity in your answer.  0.93. What is the ratio of the Rating (1=underdeveloped to 7=well developed) in Hungary in 2010 to that in 2013?
Provide a succinct answer. 1.03. What is the ratio of the Rating (1=underdeveloped to 7=well developed) in Low & middle income in 2010 to that in 2014?
Ensure brevity in your answer.  1.06. What is the ratio of the Rating (1=underdeveloped to 7=well developed) of Croatia in 2010 to that in 2014?
Ensure brevity in your answer.  0.87. What is the ratio of the Rating (1=underdeveloped to 7=well developed) of Hungary in 2010 to that in 2014?
Offer a very short reply. 1.06. What is the ratio of the Rating (1=underdeveloped to 7=well developed) in Low & middle income in 2011 to that in 2012?
Make the answer very short. 1. What is the ratio of the Rating (1=underdeveloped to 7=well developed) in Low & middle income in 2011 to that in 2013?
Keep it short and to the point. 1.01. What is the ratio of the Rating (1=underdeveloped to 7=well developed) in Croatia in 2011 to that in 2013?
Make the answer very short. 0.93. What is the ratio of the Rating (1=underdeveloped to 7=well developed) of Hungary in 2011 to that in 2013?
Your answer should be compact. 1.03. What is the ratio of the Rating (1=underdeveloped to 7=well developed) of Low & middle income in 2011 to that in 2014?
Offer a terse response. 1.05. What is the ratio of the Rating (1=underdeveloped to 7=well developed) in Croatia in 2011 to that in 2014?
Your answer should be compact. 0.87. What is the ratio of the Rating (1=underdeveloped to 7=well developed) of Hungary in 2011 to that in 2014?
Give a very brief answer. 1.05. What is the ratio of the Rating (1=underdeveloped to 7=well developed) in Low & middle income in 2012 to that in 2013?
Keep it short and to the point. 1.02. What is the ratio of the Rating (1=underdeveloped to 7=well developed) of Croatia in 2012 to that in 2013?
Your answer should be very brief. 0.93. What is the ratio of the Rating (1=underdeveloped to 7=well developed) in Hungary in 2012 to that in 2013?
Ensure brevity in your answer.  1.03. What is the ratio of the Rating (1=underdeveloped to 7=well developed) of Low & middle income in 2012 to that in 2014?
Offer a very short reply. 1.06. What is the ratio of the Rating (1=underdeveloped to 7=well developed) of Croatia in 2012 to that in 2014?
Your answer should be very brief. 0.87. What is the ratio of the Rating (1=underdeveloped to 7=well developed) in Hungary in 2012 to that in 2014?
Give a very brief answer. 1.05. What is the ratio of the Rating (1=underdeveloped to 7=well developed) of Low & middle income in 2013 to that in 2014?
Your response must be concise. 1.04. What is the ratio of the Rating (1=underdeveloped to 7=well developed) of Croatia in 2013 to that in 2014?
Your response must be concise. 0.93. What is the ratio of the Rating (1=underdeveloped to 7=well developed) of Hungary in 2013 to that in 2014?
Your response must be concise. 1.03. What is the difference between the highest and the second highest Rating (1=underdeveloped to 7=well developed) of Low & middle income?
Offer a very short reply. 0.02. What is the difference between the highest and the second highest Rating (1=underdeveloped to 7=well developed) in Hungary?
Keep it short and to the point. 0.01. What is the difference between the highest and the lowest Rating (1=underdeveloped to 7=well developed) in Low & middle income?
Ensure brevity in your answer.  0.36. What is the difference between the highest and the lowest Rating (1=underdeveloped to 7=well developed) of Croatia?
Give a very brief answer. 1.32. What is the difference between the highest and the lowest Rating (1=underdeveloped to 7=well developed) of Hungary?
Offer a very short reply. 0.31. 